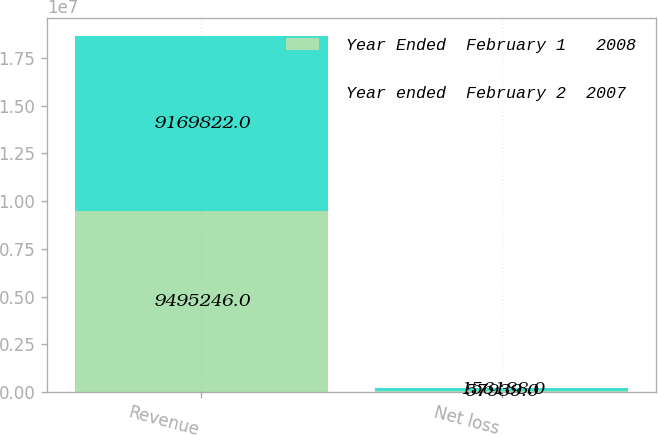<chart> <loc_0><loc_0><loc_500><loc_500><stacked_bar_chart><ecel><fcel>Revenue<fcel>Net loss<nl><fcel>Year Ended  February 1   2008<fcel>9.49525e+06<fcel>57939<nl><fcel>Year ended  February 2  2007<fcel>9.16982e+06<fcel>156188<nl></chart> 